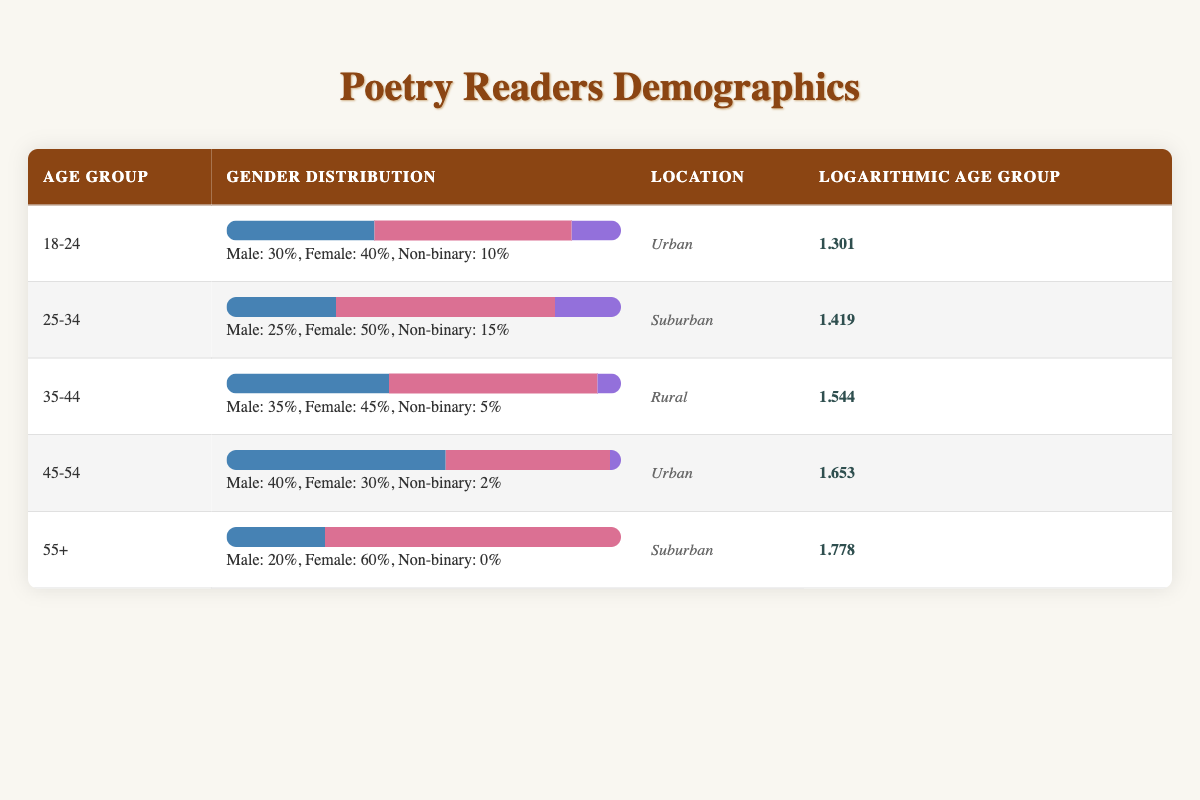What is the logarithmic value for the age group 25-34? The table lists the logarithmic age group values, and for the age group 25-34, it is directly specified as 1.419.
Answer: 1.419 Which age group has the highest percentage of female poetry readers? By examining the gender distribution for each age group, the 55+ group has the highest percentage of female readers at 60%.
Answer: 55+ What is the total number of male poetry readers across all age groups? Adding the male readers from each age group gives: 30 + 25 + 35 + 40 + 20 = 150. Therefore, the total is 150.
Answer: 150 Is there a non-binary readership in the age group 45-54? The data shows that in the age group 45-54, there are only 2 non-binary readers, indicating the existence of non-binary readership in this age group.
Answer: Yes What is the difference in logarithmic values between the age groups 18-24 and 55+? To find the difference, subtract the logarithmic value of the 18-24 group (1.301) from that of the 55+ group (1.778). The calculation is 1.778 - 1.301 = 0.477.
Answer: 0.477 Which location has the highest percentage of male readers? Analyzing the locations, the Urban area in the 45-54 age group shows the highest percentage of male readers at 40%.
Answer: Urban Calculate the average percentage of non-binary readers across all age groups. The non-binary percentages are 10%, 15%, 5%, 2%, and 0%. Summing these gives 32%, and averaging by dividing by 5 gives an average of 6.4%.
Answer: 6.4% How many total poetry readers are identified in the rural location? Looking at the Rural location, we have: 35 (male) + 45 (female) + 5 (non-binary) = 85 total readers.
Answer: 85 Does the age group 35-44 have more male or female readers? In the 35-44 age group, there are 35 male and 45 female readers, indicating that female readers outnumber male readers in this group.
Answer: Female readers are more 